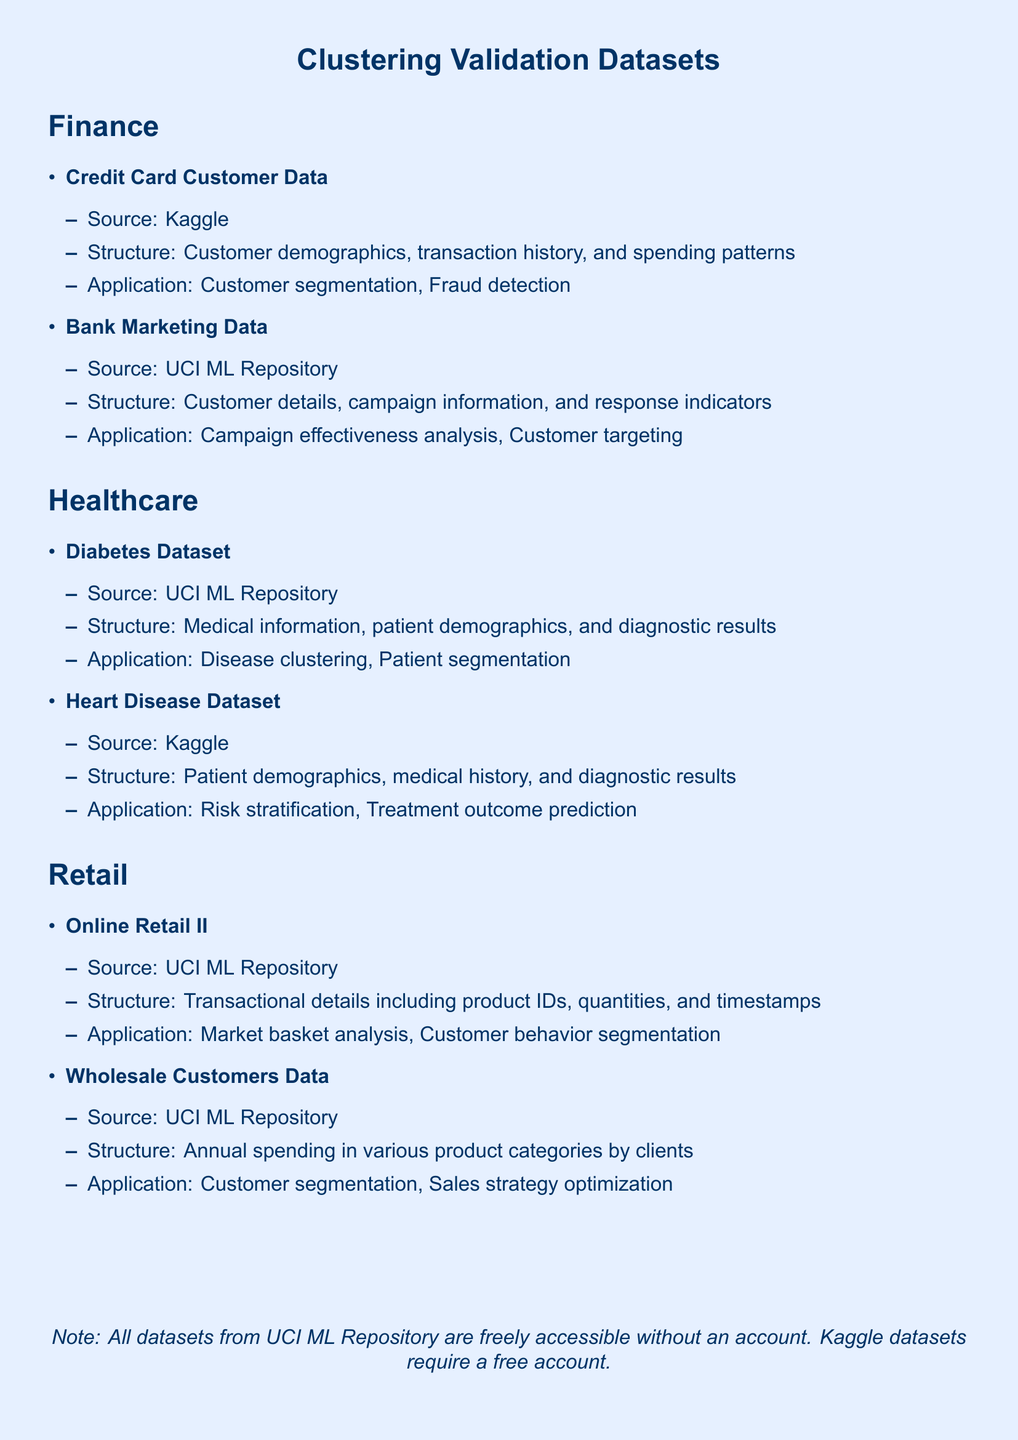What is the source of the Credit Card Customer Data? The document states that Credit Card Customer Data comes from Kaggle.
Answer: Kaggle What are the typical application areas for the Diabetes Dataset? The document lists disease clustering and patient segmentation as application areas for the Diabetes Dataset.
Answer: Disease clustering, Patient segmentation How many datasets are listed under the Healthcare section? The document specifies two datasets under the Healthcare section: Diabetes Dataset and Heart Disease Dataset.
Answer: 2 What structure does the Online Retail II dataset have? The document describes the structure of the Online Retail II dataset as transactional details including product IDs, quantities, and timestamps.
Answer: Transactional details including product IDs, quantities, and timestamps What is required to access Kaggle datasets? The document mentions that a free account is required to access Kaggle datasets.
Answer: Free account Which dataset is used for campaign effectiveness analysis? The document indicates that the Bank Marketing Data is used for campaign effectiveness analysis.
Answer: Bank Marketing Data How many dataset categories are present in the document? The document lists three categories: Finance, Healthcare, and Retail.
Answer: 3 What is the common source of datasets in the document? The document highlights UCI ML Repository as a common source for several datasets.
Answer: UCI ML Repository For which dataset is risk stratification a typical application? The document states that risk stratification is a typical application for the Heart Disease Dataset.
Answer: Heart Disease Dataset 